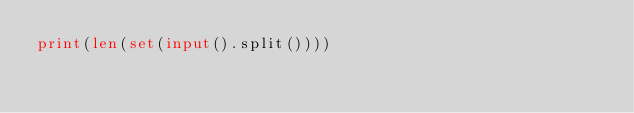<code> <loc_0><loc_0><loc_500><loc_500><_Python_>print(len(set(input().split())))</code> 